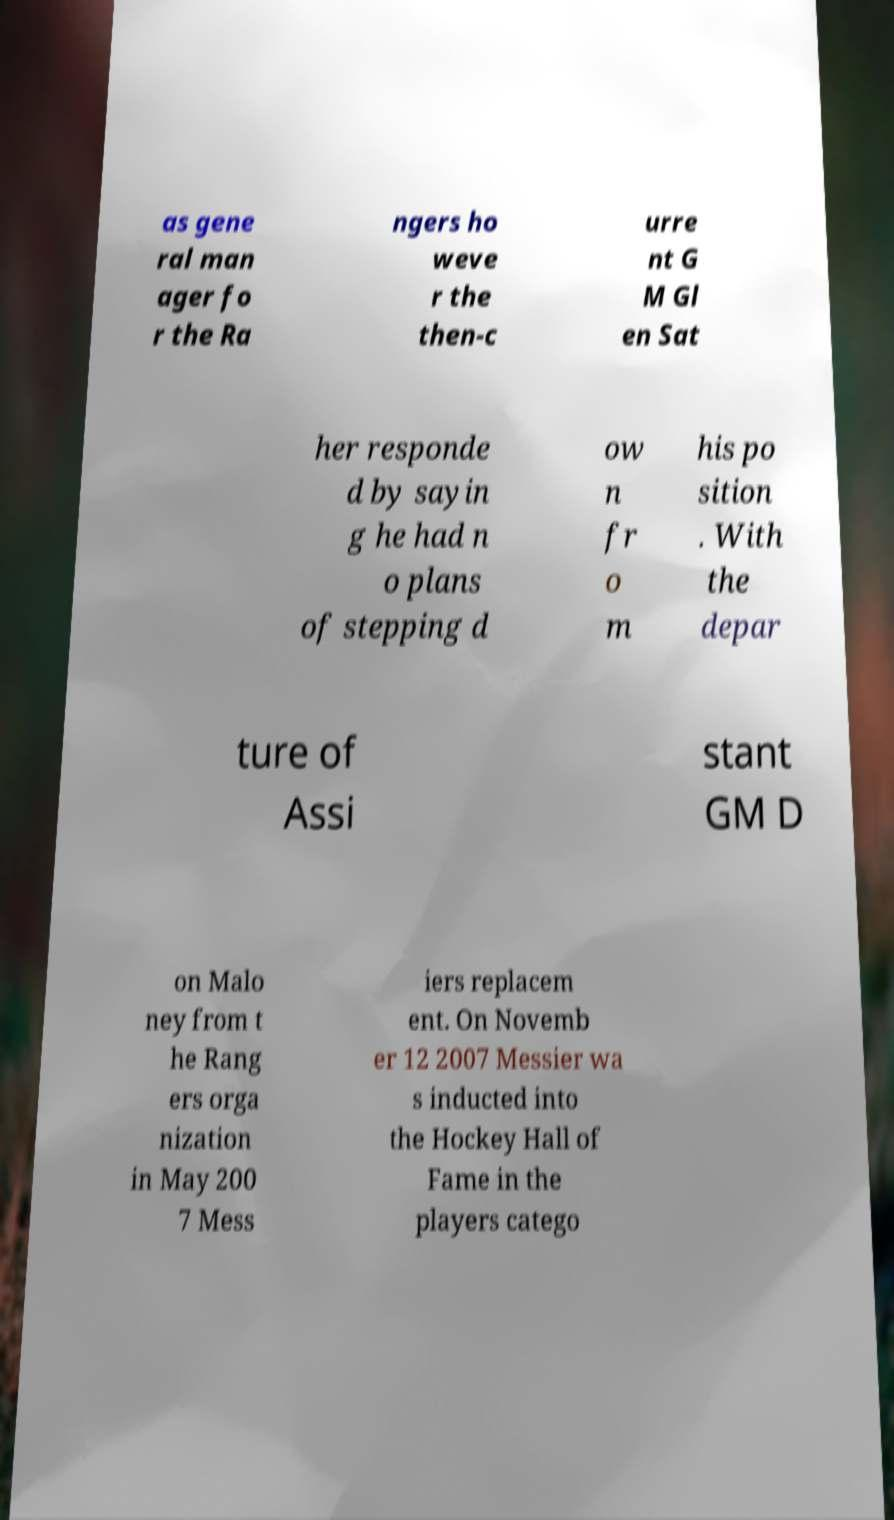What messages or text are displayed in this image? I need them in a readable, typed format. as gene ral man ager fo r the Ra ngers ho weve r the then-c urre nt G M Gl en Sat her responde d by sayin g he had n o plans of stepping d ow n fr o m his po sition . With the depar ture of Assi stant GM D on Malo ney from t he Rang ers orga nization in May 200 7 Mess iers replacem ent. On Novemb er 12 2007 Messier wa s inducted into the Hockey Hall of Fame in the players catego 